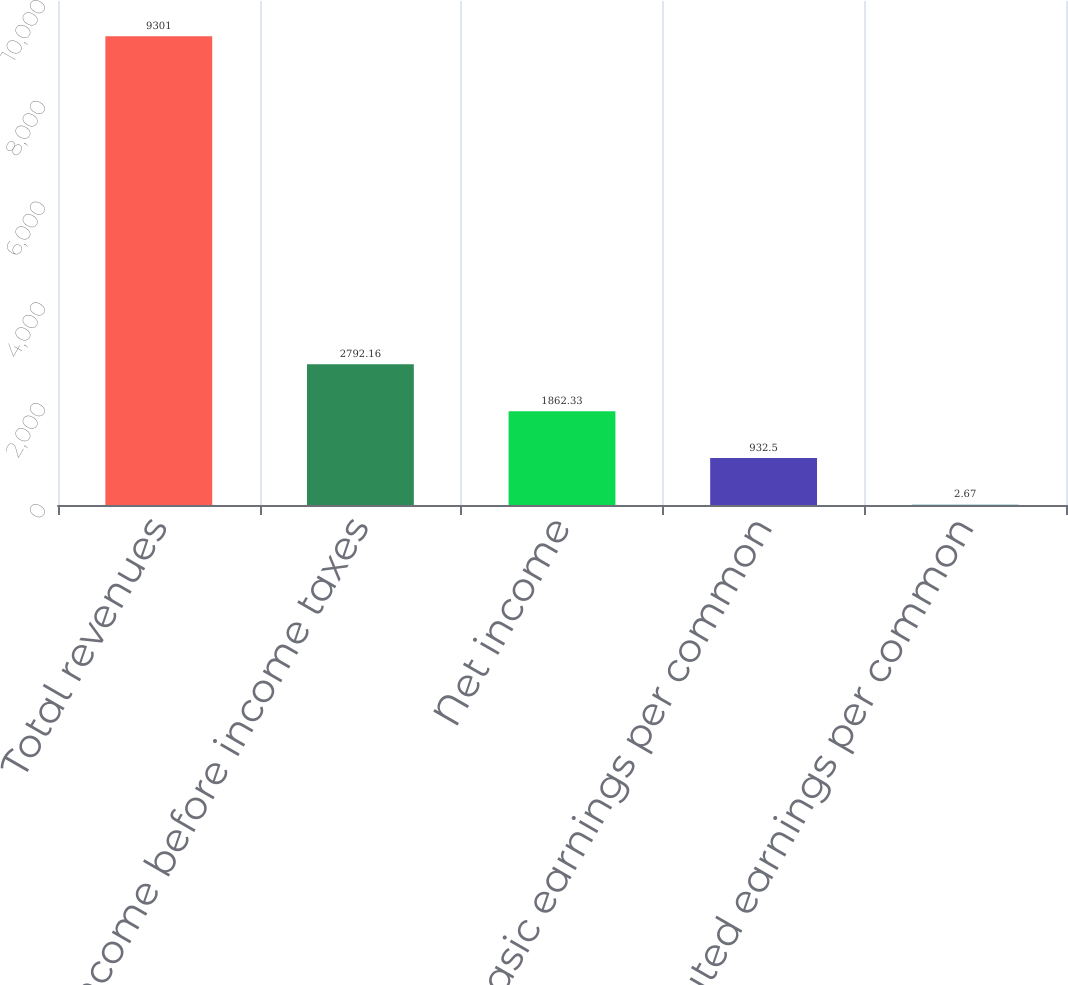<chart> <loc_0><loc_0><loc_500><loc_500><bar_chart><fcel>Total revenues<fcel>Income before income taxes<fcel>Net income<fcel>Basic earnings per common<fcel>Diluted earnings per common<nl><fcel>9301<fcel>2792.16<fcel>1862.33<fcel>932.5<fcel>2.67<nl></chart> 